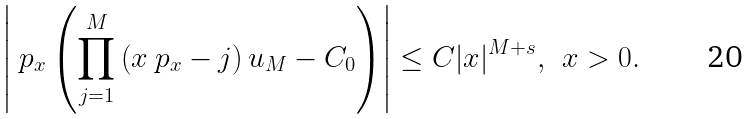<formula> <loc_0><loc_0><loc_500><loc_500>\left | \ p _ { x } \left ( \prod _ { j = 1 } ^ { M } \left ( x \ p _ { x } - j \right ) u _ { M } - C _ { 0 } \right ) \right | \leq C | x | ^ { M + s } , \, \ x > 0 .</formula> 